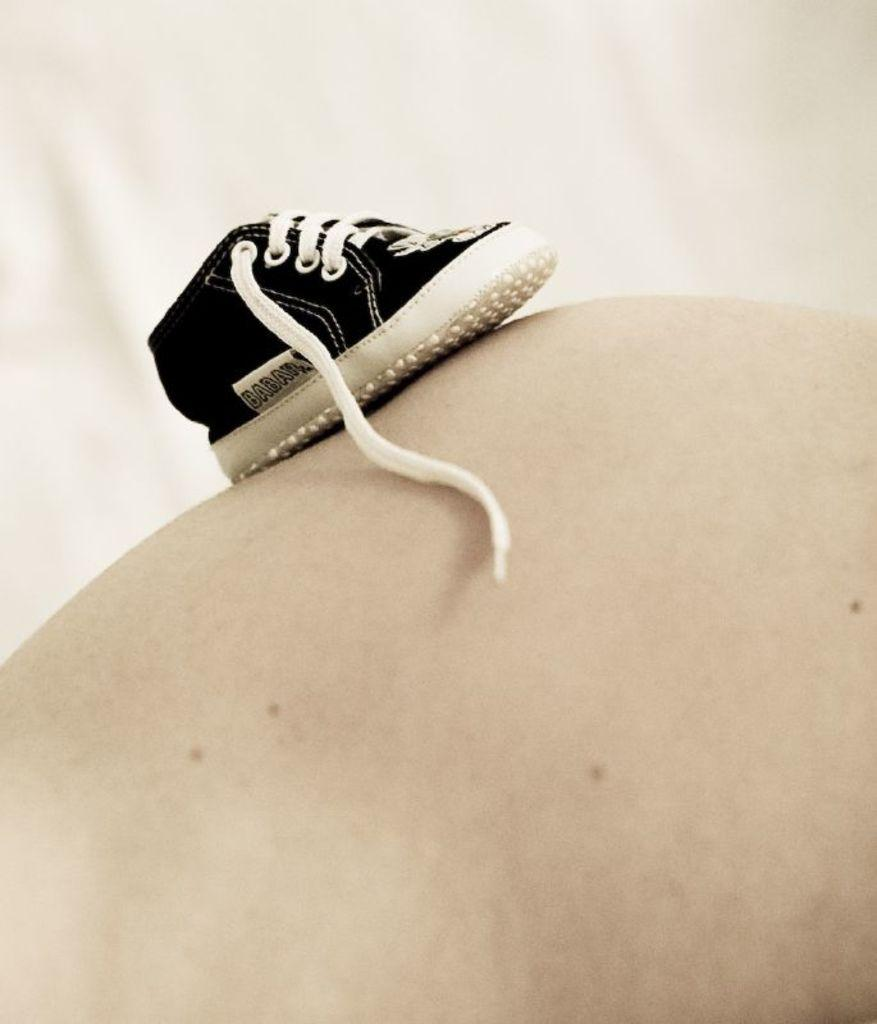What object is the main subject of the image? There is a shoe in the image. What color is the background of the image? The background of the image is white. How does the shoe apply the brake in the image? There is no indication of a brake or any vehicle in the image; it only features a shoe. 